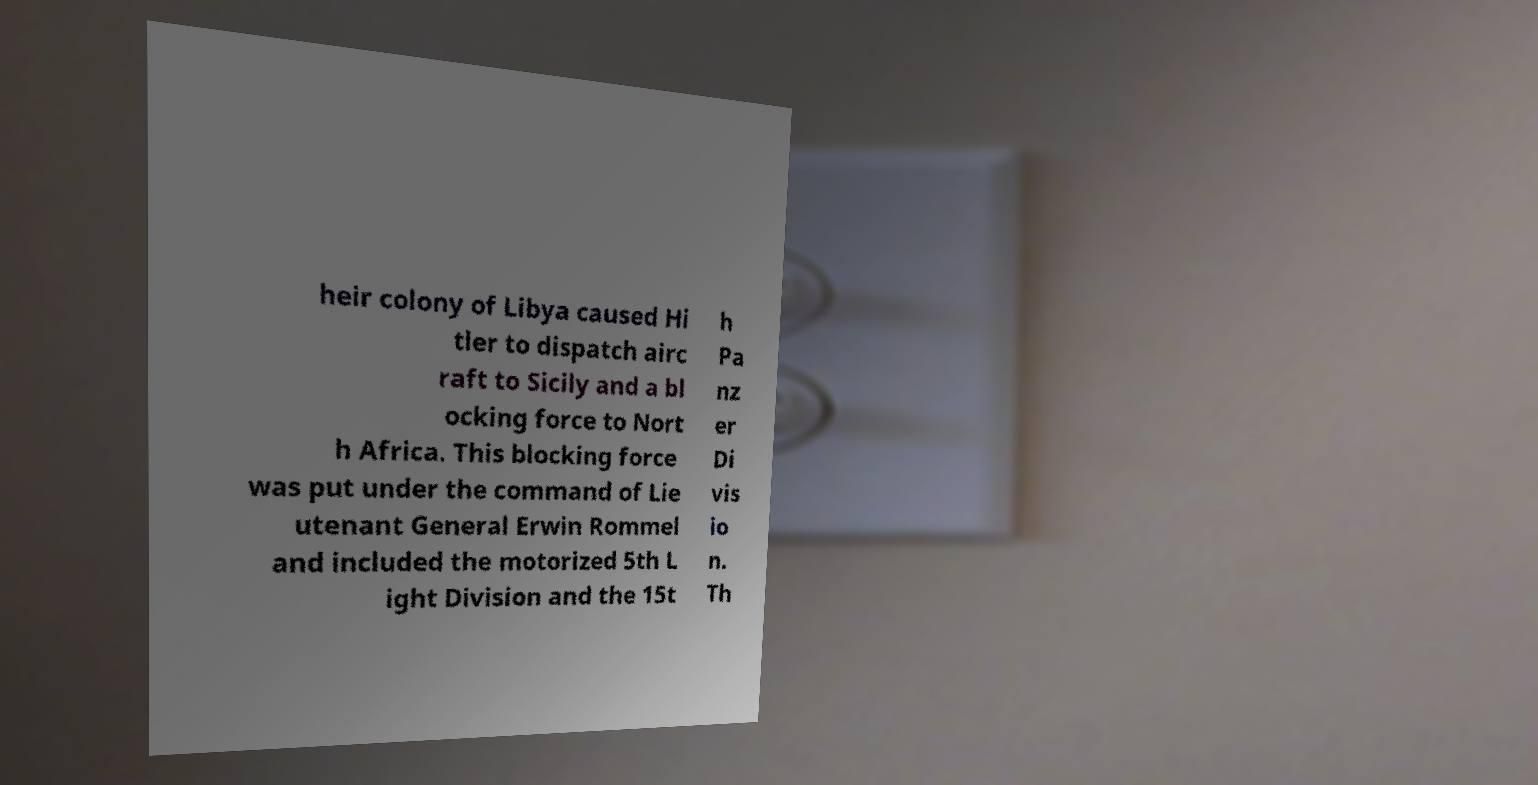There's text embedded in this image that I need extracted. Can you transcribe it verbatim? heir colony of Libya caused Hi tler to dispatch airc raft to Sicily and a bl ocking force to Nort h Africa. This blocking force was put under the command of Lie utenant General Erwin Rommel and included the motorized 5th L ight Division and the 15t h Pa nz er Di vis io n. Th 